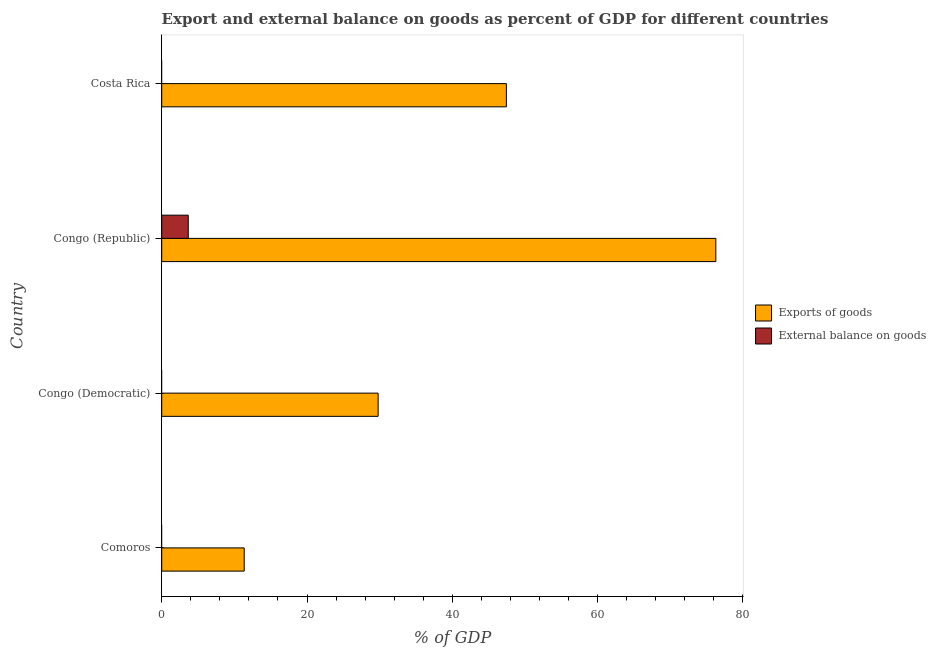How many different coloured bars are there?
Your answer should be compact. 2. Are the number of bars per tick equal to the number of legend labels?
Keep it short and to the point. No. How many bars are there on the 4th tick from the top?
Offer a very short reply. 1. How many bars are there on the 1st tick from the bottom?
Offer a terse response. 1. What is the label of the 3rd group of bars from the top?
Offer a very short reply. Congo (Democratic). In how many cases, is the number of bars for a given country not equal to the number of legend labels?
Offer a very short reply. 3. Across all countries, what is the maximum export of goods as percentage of gdp?
Provide a succinct answer. 76.28. In which country was the export of goods as percentage of gdp maximum?
Your response must be concise. Congo (Republic). What is the total external balance on goods as percentage of gdp in the graph?
Your answer should be very brief. 3.65. What is the difference between the export of goods as percentage of gdp in Congo (Republic) and that in Costa Rica?
Provide a short and direct response. 28.83. What is the difference between the export of goods as percentage of gdp in Costa Rica and the external balance on goods as percentage of gdp in Comoros?
Make the answer very short. 47.44. What is the average export of goods as percentage of gdp per country?
Offer a very short reply. 41.22. What is the difference between the export of goods as percentage of gdp and external balance on goods as percentage of gdp in Congo (Republic)?
Ensure brevity in your answer.  72.62. In how many countries, is the external balance on goods as percentage of gdp greater than 28 %?
Provide a short and direct response. 0. What is the ratio of the export of goods as percentage of gdp in Congo (Democratic) to that in Costa Rica?
Provide a short and direct response. 0.63. Is the export of goods as percentage of gdp in Comoros less than that in Costa Rica?
Offer a very short reply. Yes. What is the difference between the highest and the second highest export of goods as percentage of gdp?
Give a very brief answer. 28.83. What is the difference between the highest and the lowest external balance on goods as percentage of gdp?
Offer a very short reply. 3.65. In how many countries, is the external balance on goods as percentage of gdp greater than the average external balance on goods as percentage of gdp taken over all countries?
Your response must be concise. 1. How many countries are there in the graph?
Ensure brevity in your answer.  4. Does the graph contain any zero values?
Offer a terse response. Yes. How many legend labels are there?
Offer a very short reply. 2. How are the legend labels stacked?
Provide a succinct answer. Vertical. What is the title of the graph?
Offer a terse response. Export and external balance on goods as percent of GDP for different countries. Does "Resident" appear as one of the legend labels in the graph?
Offer a very short reply. No. What is the label or title of the X-axis?
Keep it short and to the point. % of GDP. What is the % of GDP of Exports of goods in Comoros?
Give a very brief answer. 11.35. What is the % of GDP in Exports of goods in Congo (Democratic)?
Your answer should be very brief. 29.79. What is the % of GDP in External balance on goods in Congo (Democratic)?
Offer a very short reply. 0. What is the % of GDP in Exports of goods in Congo (Republic)?
Offer a very short reply. 76.28. What is the % of GDP of External balance on goods in Congo (Republic)?
Your answer should be compact. 3.65. What is the % of GDP in Exports of goods in Costa Rica?
Provide a succinct answer. 47.44. Across all countries, what is the maximum % of GDP in Exports of goods?
Offer a terse response. 76.28. Across all countries, what is the maximum % of GDP in External balance on goods?
Provide a short and direct response. 3.65. Across all countries, what is the minimum % of GDP of Exports of goods?
Your answer should be very brief. 11.35. What is the total % of GDP of Exports of goods in the graph?
Ensure brevity in your answer.  164.87. What is the total % of GDP of External balance on goods in the graph?
Give a very brief answer. 3.65. What is the difference between the % of GDP of Exports of goods in Comoros and that in Congo (Democratic)?
Keep it short and to the point. -18.44. What is the difference between the % of GDP of Exports of goods in Comoros and that in Congo (Republic)?
Offer a terse response. -64.92. What is the difference between the % of GDP in Exports of goods in Comoros and that in Costa Rica?
Provide a short and direct response. -36.09. What is the difference between the % of GDP in Exports of goods in Congo (Democratic) and that in Congo (Republic)?
Your answer should be very brief. -46.49. What is the difference between the % of GDP of Exports of goods in Congo (Democratic) and that in Costa Rica?
Make the answer very short. -17.65. What is the difference between the % of GDP of Exports of goods in Congo (Republic) and that in Costa Rica?
Provide a short and direct response. 28.83. What is the difference between the % of GDP of Exports of goods in Comoros and the % of GDP of External balance on goods in Congo (Republic)?
Keep it short and to the point. 7.7. What is the difference between the % of GDP in Exports of goods in Congo (Democratic) and the % of GDP in External balance on goods in Congo (Republic)?
Provide a short and direct response. 26.14. What is the average % of GDP of Exports of goods per country?
Your answer should be compact. 41.22. What is the average % of GDP in External balance on goods per country?
Keep it short and to the point. 0.91. What is the difference between the % of GDP of Exports of goods and % of GDP of External balance on goods in Congo (Republic)?
Provide a short and direct response. 72.62. What is the ratio of the % of GDP of Exports of goods in Comoros to that in Congo (Democratic)?
Your answer should be compact. 0.38. What is the ratio of the % of GDP in Exports of goods in Comoros to that in Congo (Republic)?
Your response must be concise. 0.15. What is the ratio of the % of GDP of Exports of goods in Comoros to that in Costa Rica?
Offer a very short reply. 0.24. What is the ratio of the % of GDP of Exports of goods in Congo (Democratic) to that in Congo (Republic)?
Offer a terse response. 0.39. What is the ratio of the % of GDP of Exports of goods in Congo (Democratic) to that in Costa Rica?
Your response must be concise. 0.63. What is the ratio of the % of GDP in Exports of goods in Congo (Republic) to that in Costa Rica?
Offer a terse response. 1.61. What is the difference between the highest and the second highest % of GDP in Exports of goods?
Your answer should be compact. 28.83. What is the difference between the highest and the lowest % of GDP of Exports of goods?
Provide a short and direct response. 64.92. What is the difference between the highest and the lowest % of GDP in External balance on goods?
Provide a succinct answer. 3.65. 